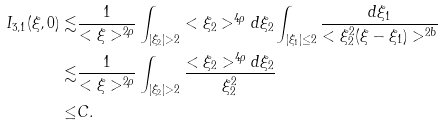Convert formula to latex. <formula><loc_0><loc_0><loc_500><loc_500>I _ { 3 , 1 } ( \xi , 0 ) \lesssim & \frac { 1 } { < \xi > ^ { 2 \rho } } \int _ { | \xi _ { 2 } | > 2 } < \xi _ { 2 } > ^ { 4 \rho } d \xi _ { 2 } \int _ { | \xi _ { 1 } | \leq 2 } \frac { d \xi _ { 1 } } { < \xi _ { 2 } ^ { 2 } ( \xi - \xi _ { 1 } ) > ^ { 2 b } } \\ \lesssim & \frac { 1 } { < \xi > ^ { 2 \rho } } \int _ { | \xi _ { 2 } | > 2 } \frac { < \xi _ { 2 } > ^ { 4 \rho } d \xi _ { 2 } } { \xi _ { 2 } ^ { 2 } } \\ \leq & C .</formula> 